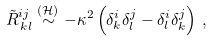<formula> <loc_0><loc_0><loc_500><loc_500>\tilde { R } ^ { i j } _ { \, k l } \stackrel { ( \mathcal { H } ) } { \sim } - \kappa ^ { 2 } \left ( \delta ^ { i } _ { k } \delta ^ { j } _ { l } - \delta ^ { i } _ { l } \delta ^ { j } _ { k } \right ) \, ,</formula> 